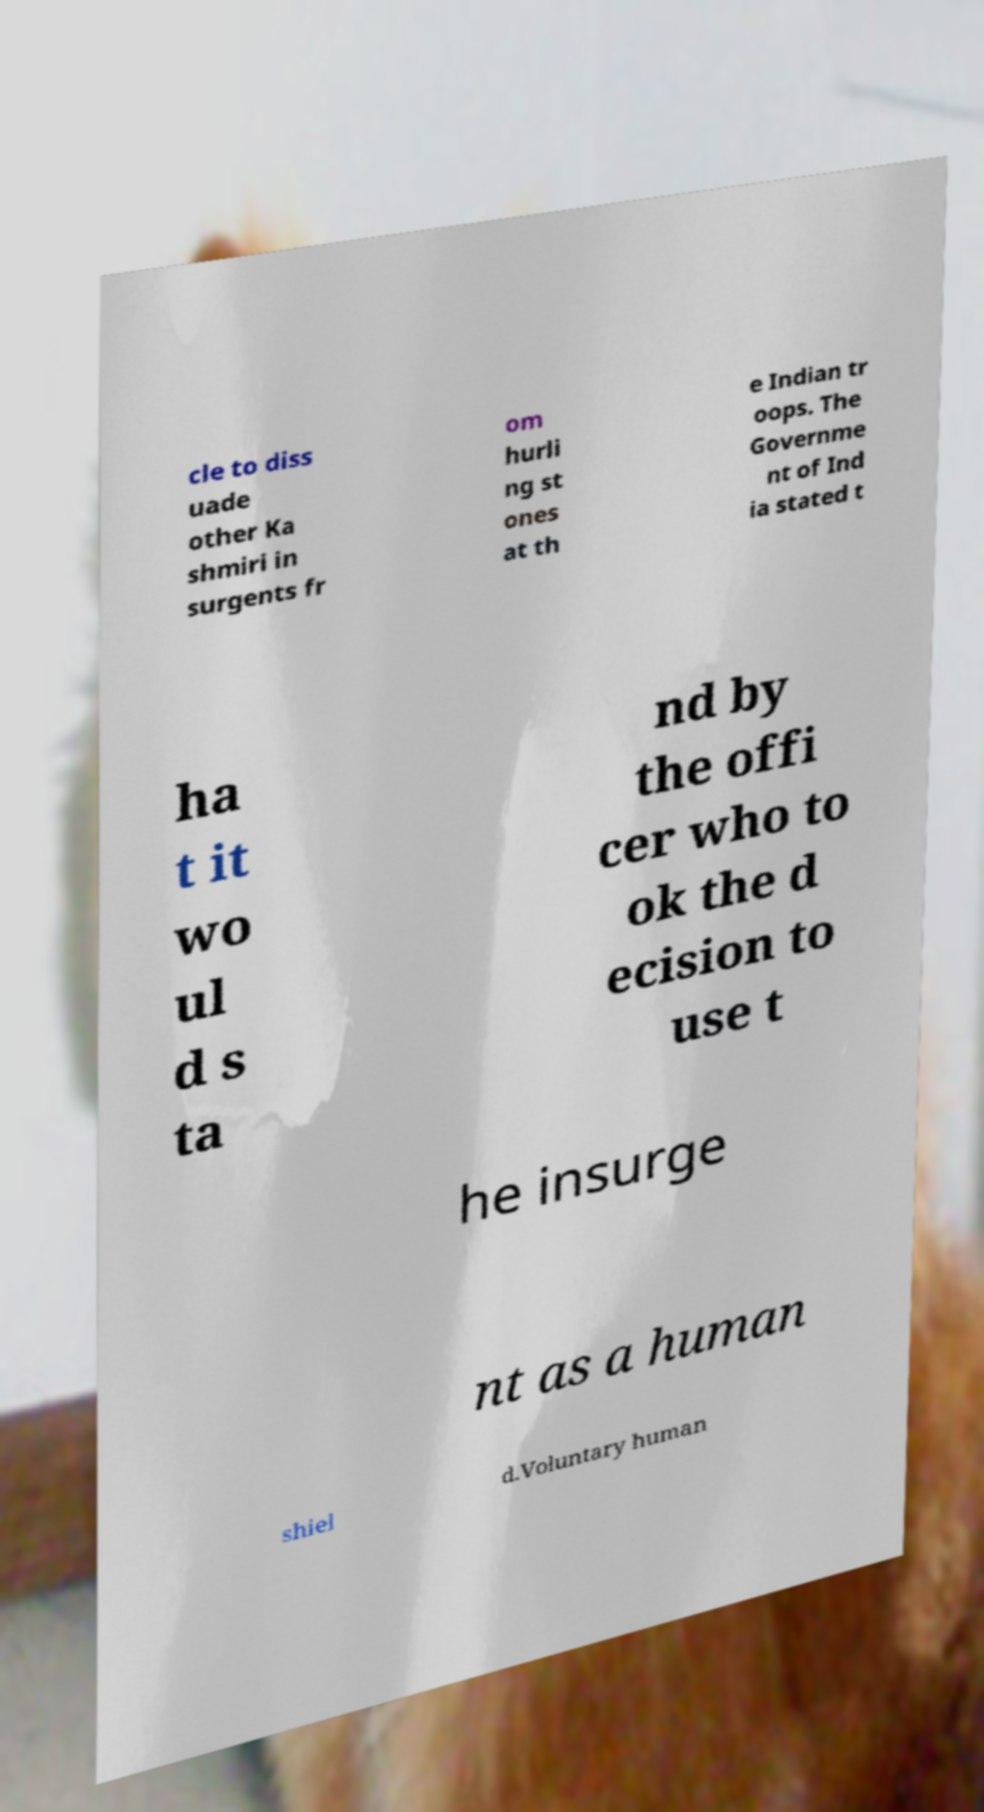Can you accurately transcribe the text from the provided image for me? cle to diss uade other Ka shmiri in surgents fr om hurli ng st ones at th e Indian tr oops. The Governme nt of Ind ia stated t ha t it wo ul d s ta nd by the offi cer who to ok the d ecision to use t he insurge nt as a human shiel d.Voluntary human 